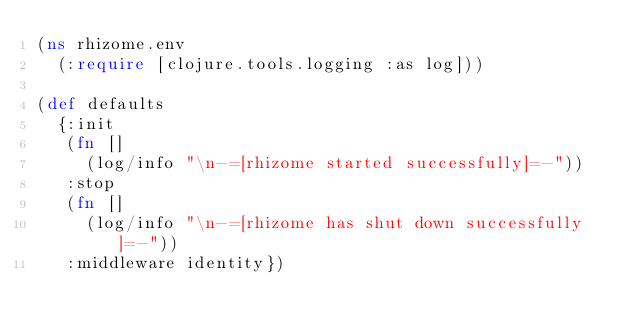Convert code to text. <code><loc_0><loc_0><loc_500><loc_500><_Clojure_>(ns rhizome.env
  (:require [clojure.tools.logging :as log]))

(def defaults
  {:init
   (fn []
     (log/info "\n-=[rhizome started successfully]=-"))
   :stop
   (fn []
     (log/info "\n-=[rhizome has shut down successfully]=-"))
   :middleware identity})
</code> 